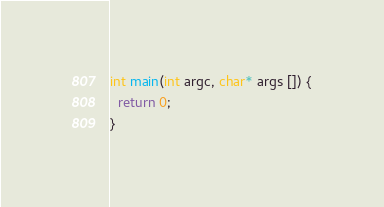<code> <loc_0><loc_0><loc_500><loc_500><_C++_>int main(int argc, char* args []) {
  return 0;
}</code> 